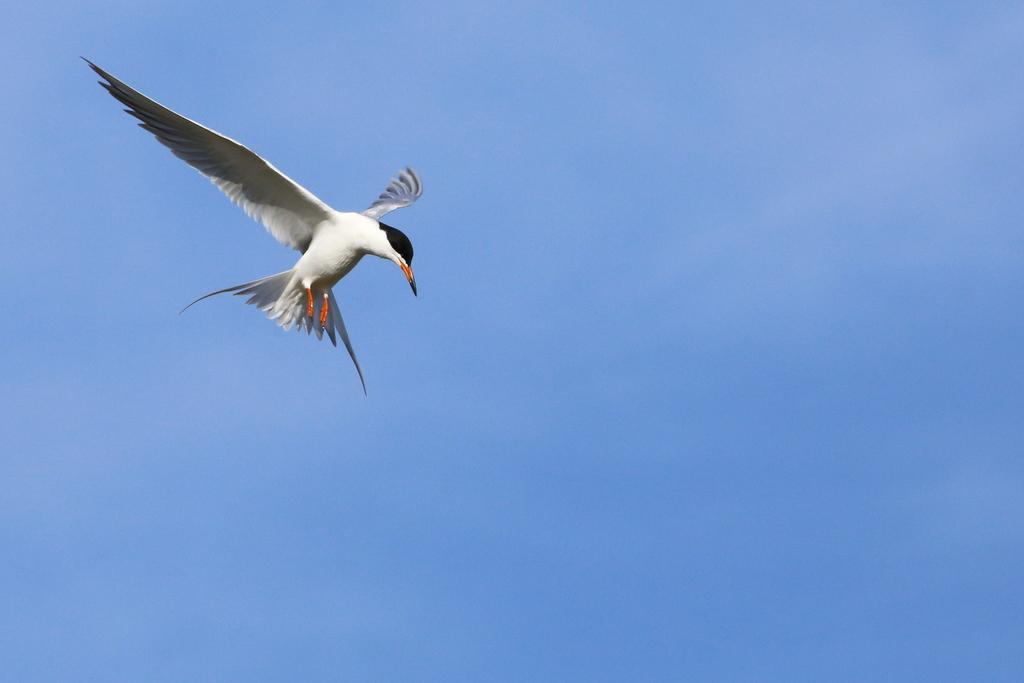What type of animal can be seen in the image in the image? There is a white color bird in the image. What is the bird doing in the image? The bird is flying in the air. What can be seen in the background of the image? The sky is visible in the background of the image. What is the color of the sky in the image? The color of the sky is blue. Is there a mitten present in the image? No, there is no mitten present in the image. Can you tell me how much the bird has paid for its flight in the image? There is no payment involved in the bird's flight in the image; it is a natural action for birds. 